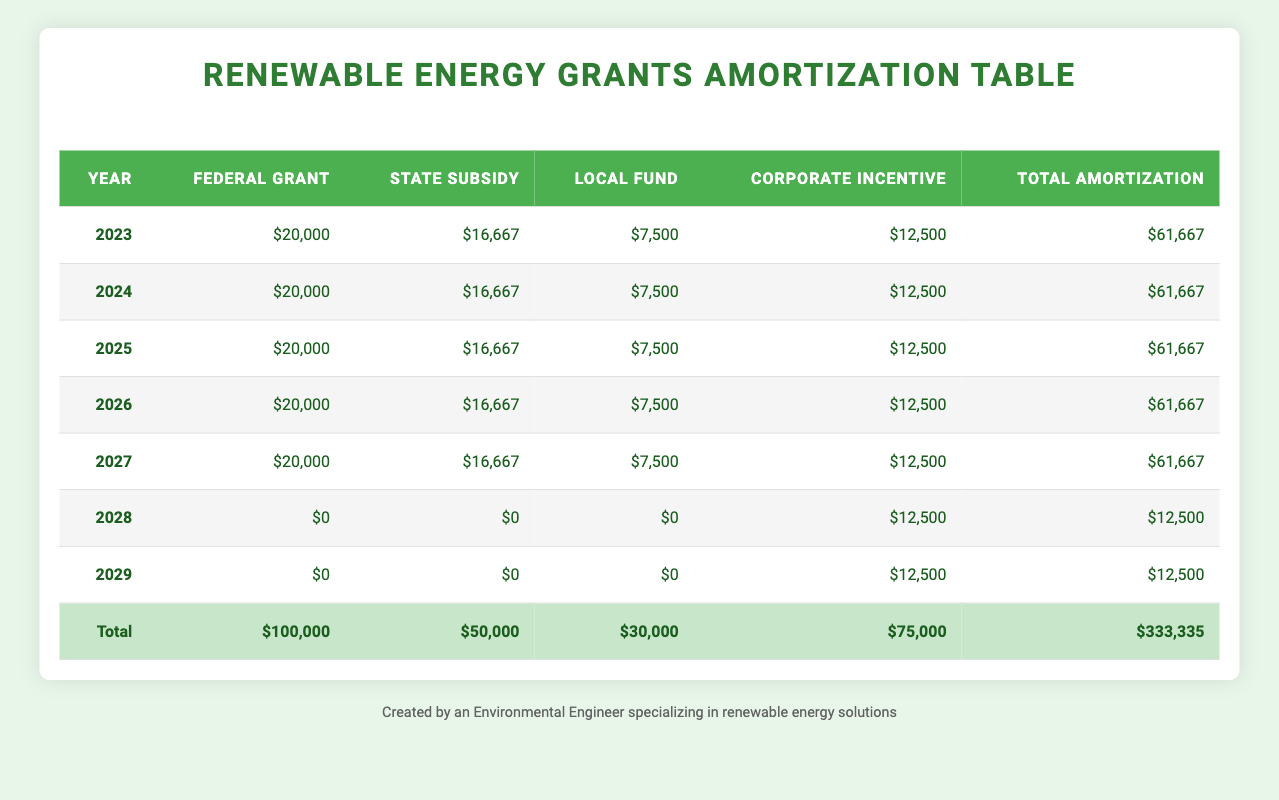What is the total amortization for the year 2025? The table lists the total amortization for each year. For the year 2025, the total amortization is directly stated as $61,667.
Answer: $61,667 Which grant has the highest amortization per year? The table shows the amortization for each grant type for the same years. The Federal Renewable Energy Grant, State Green Energy Subsidy, and Local Solar Innovation Fund all have annual amortizations of $20,000, $16,667, and $7,500 respectively for the first five years, but the Corporate Incentive allows for $12,500 starting from the fifth year onward. However, the Federal Grant has the highest consistent value at $20,000 per year.
Answer: Federal Renewable Energy Grant How much total funding was amortized from State Green Energy Subsidy over its duration? The State Green Energy Subsidy has a total amortization of $16,667 each year for three years (2023 to 2026). So calculating the total: 3 years x $16,667 = $50,001.
Answer: $50,001 Is the amortization for all grants and subsidies zero in 2028 and 2029 for the specified terms? The table indicates that the amortization for the Federal Grant, State Subsidy, and Local Fund is $0 for both years 2028 and 2029. For the Corporate Incentive, there is still an amortization of $12,500 each year. Therefore, not all grants have zero amortization in these years.
Answer: No What was the total amount amortized across all grants in 2026? To find the total for 2026, the values from the table must be summed: $20,000 (Federal) + $16,667 (State) + $7,500 (Local) + $12,500 (Corporate) = $61,667. Thus, the total amount amortized in that year is $61,667.
Answer: $61,667 How does the total amortization of 2027 compare to that of 2028? The total amortization for 2027 is $61,667, while for 2028 it is $12,500. The 2027 total is significantly higher than that of 2028 by $49,167, indicating that most of the grants are fully amortized by 2028.
Answer: 2027 is higher by $49,167 What is the average annual amortization from the Local Solar Innovation Fund over its duration? The Local Solar Innovation Fund has an amortization of $7,500 for 4 years (2023 to 2027), so the total amount over these years is $30,000. To find the average: $30,000 / 4 = $7,500.
Answer: $7,500 Have all the grants been fully amortized by the end of their duration? By checking the table values, both the Federal and State grants complete their amortization during their terms. Meanwhile, the Local Fund is fully amortized by the end of its 4-year term too, and the Corporate Incentive continues for an additional two years, indicating it has not been fully amortized by 2029. Therefore, not all grants are fully amortized at their end terms.
Answer: No 